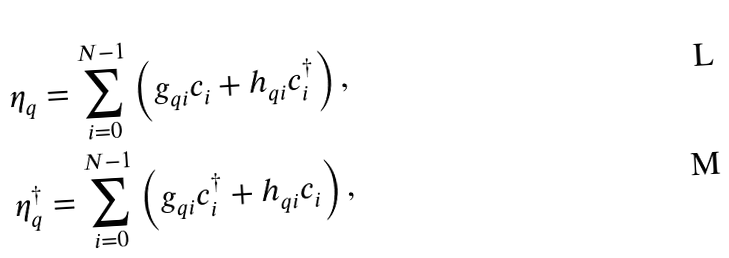Convert formula to latex. <formula><loc_0><loc_0><loc_500><loc_500>\eta _ { q } & = \sum _ { i = 0 } ^ { N - 1 } \left ( g _ { q i } c _ { i } + h _ { q i } c _ { i } ^ { \dag } \right ) , \\ \eta _ { q } ^ { \dagger } & = \sum _ { i = 0 } ^ { N - 1 } \left ( g _ { q i } c _ { i } ^ { \dag } + h _ { q i } c _ { i } \right ) ,</formula> 